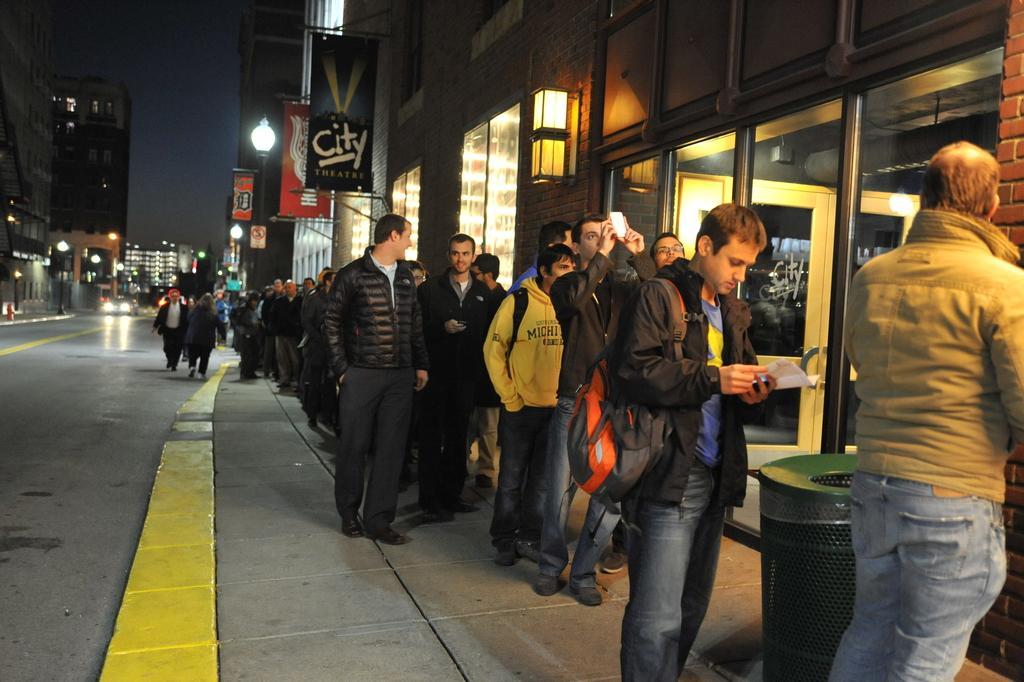Please provide a concise description of this image. In this image we can see some people standing in a queue in front of the building and there are few people walking. We can see a vehicle on the road and there are some buildings and we can see few banners with text and there is a dustbin on the right side of the image. 